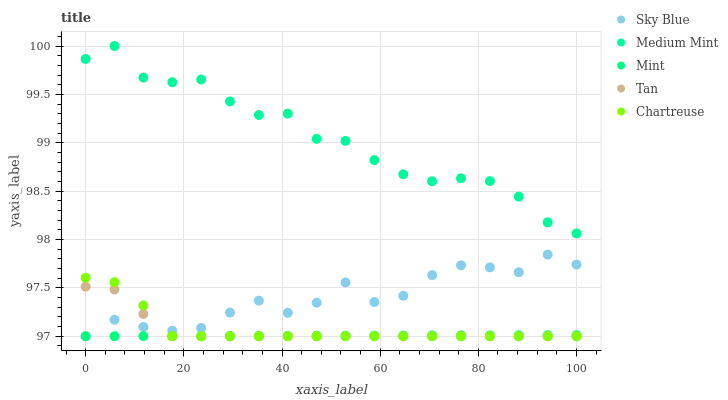Does Mint have the minimum area under the curve?
Answer yes or no. Yes. Does Medium Mint have the maximum area under the curve?
Answer yes or no. Yes. Does Sky Blue have the minimum area under the curve?
Answer yes or no. No. Does Sky Blue have the maximum area under the curve?
Answer yes or no. No. Is Mint the smoothest?
Answer yes or no. Yes. Is Sky Blue the roughest?
Answer yes or no. Yes. Is Tan the smoothest?
Answer yes or no. No. Is Tan the roughest?
Answer yes or no. No. Does Sky Blue have the lowest value?
Answer yes or no. Yes. Does Medium Mint have the highest value?
Answer yes or no. Yes. Does Sky Blue have the highest value?
Answer yes or no. No. Is Sky Blue less than Medium Mint?
Answer yes or no. Yes. Is Medium Mint greater than Chartreuse?
Answer yes or no. Yes. Does Chartreuse intersect Mint?
Answer yes or no. Yes. Is Chartreuse less than Mint?
Answer yes or no. No. Is Chartreuse greater than Mint?
Answer yes or no. No. Does Sky Blue intersect Medium Mint?
Answer yes or no. No. 